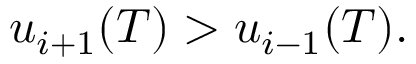Convert formula to latex. <formula><loc_0><loc_0><loc_500><loc_500>u _ { i + 1 } ( T ) > u _ { i - 1 } ( T ) .</formula> 